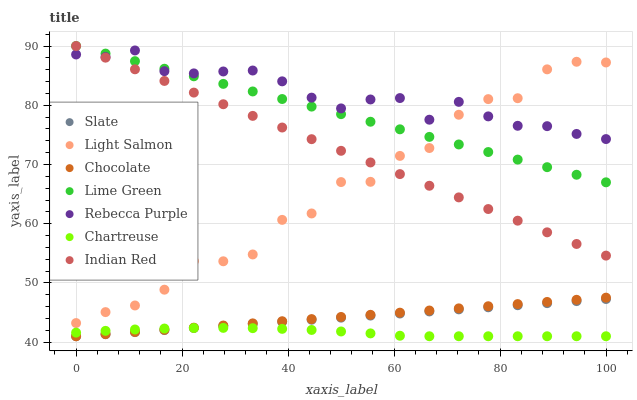Does Chartreuse have the minimum area under the curve?
Answer yes or no. Yes. Does Rebecca Purple have the maximum area under the curve?
Answer yes or no. Yes. Does Slate have the minimum area under the curve?
Answer yes or no. No. Does Slate have the maximum area under the curve?
Answer yes or no. No. Is Chocolate the smoothest?
Answer yes or no. Yes. Is Light Salmon the roughest?
Answer yes or no. Yes. Is Slate the smoothest?
Answer yes or no. No. Is Slate the roughest?
Answer yes or no. No. Does Slate have the lowest value?
Answer yes or no. Yes. Does Rebecca Purple have the lowest value?
Answer yes or no. No. Does Lime Green have the highest value?
Answer yes or no. Yes. Does Slate have the highest value?
Answer yes or no. No. Is Chartreuse less than Light Salmon?
Answer yes or no. Yes. Is Lime Green greater than Chartreuse?
Answer yes or no. Yes. Does Chartreuse intersect Chocolate?
Answer yes or no. Yes. Is Chartreuse less than Chocolate?
Answer yes or no. No. Is Chartreuse greater than Chocolate?
Answer yes or no. No. Does Chartreuse intersect Light Salmon?
Answer yes or no. No. 